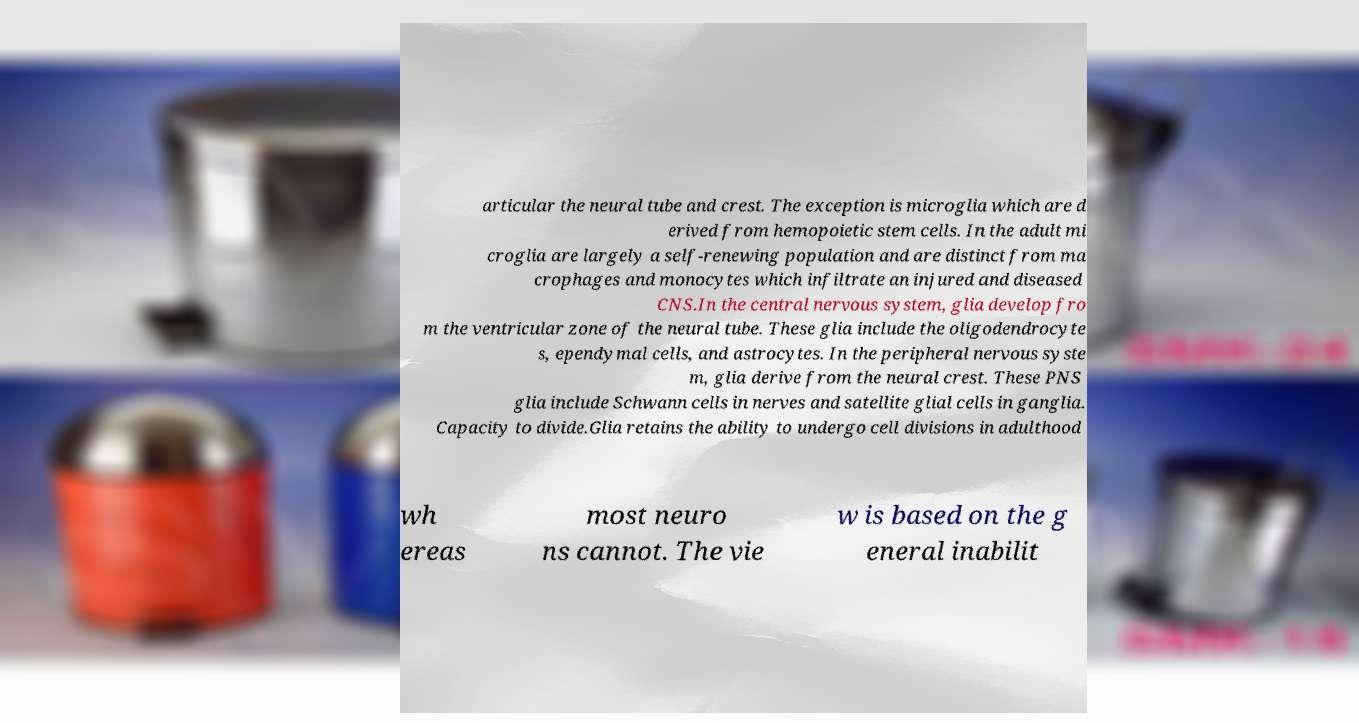Could you assist in decoding the text presented in this image and type it out clearly? articular the neural tube and crest. The exception is microglia which are d erived from hemopoietic stem cells. In the adult mi croglia are largely a self-renewing population and are distinct from ma crophages and monocytes which infiltrate an injured and diseased CNS.In the central nervous system, glia develop fro m the ventricular zone of the neural tube. These glia include the oligodendrocyte s, ependymal cells, and astrocytes. In the peripheral nervous syste m, glia derive from the neural crest. These PNS glia include Schwann cells in nerves and satellite glial cells in ganglia. Capacity to divide.Glia retains the ability to undergo cell divisions in adulthood wh ereas most neuro ns cannot. The vie w is based on the g eneral inabilit 